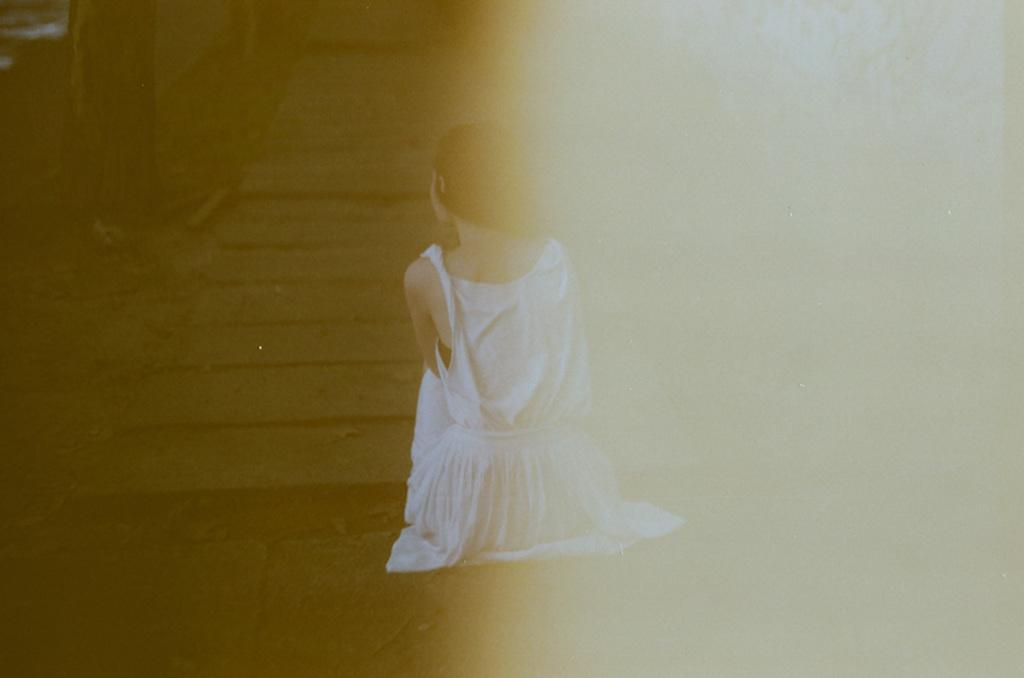What is the woman in the image doing? The woman is sitting in the image. What is the woman wearing? The woman is wearing a white dress. Can you tell if the image has been altered or edited in any way? Yes, the image has been edited. What type of cub can be seen playing with a basketball in the image? There is no cub or basketball present in the image; it features a woman sitting in a white dress. Is there a man in the image? The provided facts do not mention a man in the image, only a woman. 